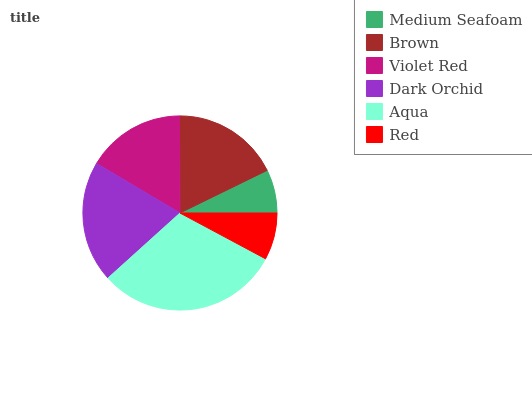Is Medium Seafoam the minimum?
Answer yes or no. Yes. Is Aqua the maximum?
Answer yes or no. Yes. Is Brown the minimum?
Answer yes or no. No. Is Brown the maximum?
Answer yes or no. No. Is Brown greater than Medium Seafoam?
Answer yes or no. Yes. Is Medium Seafoam less than Brown?
Answer yes or no. Yes. Is Medium Seafoam greater than Brown?
Answer yes or no. No. Is Brown less than Medium Seafoam?
Answer yes or no. No. Is Brown the high median?
Answer yes or no. Yes. Is Violet Red the low median?
Answer yes or no. Yes. Is Violet Red the high median?
Answer yes or no. No. Is Red the low median?
Answer yes or no. No. 